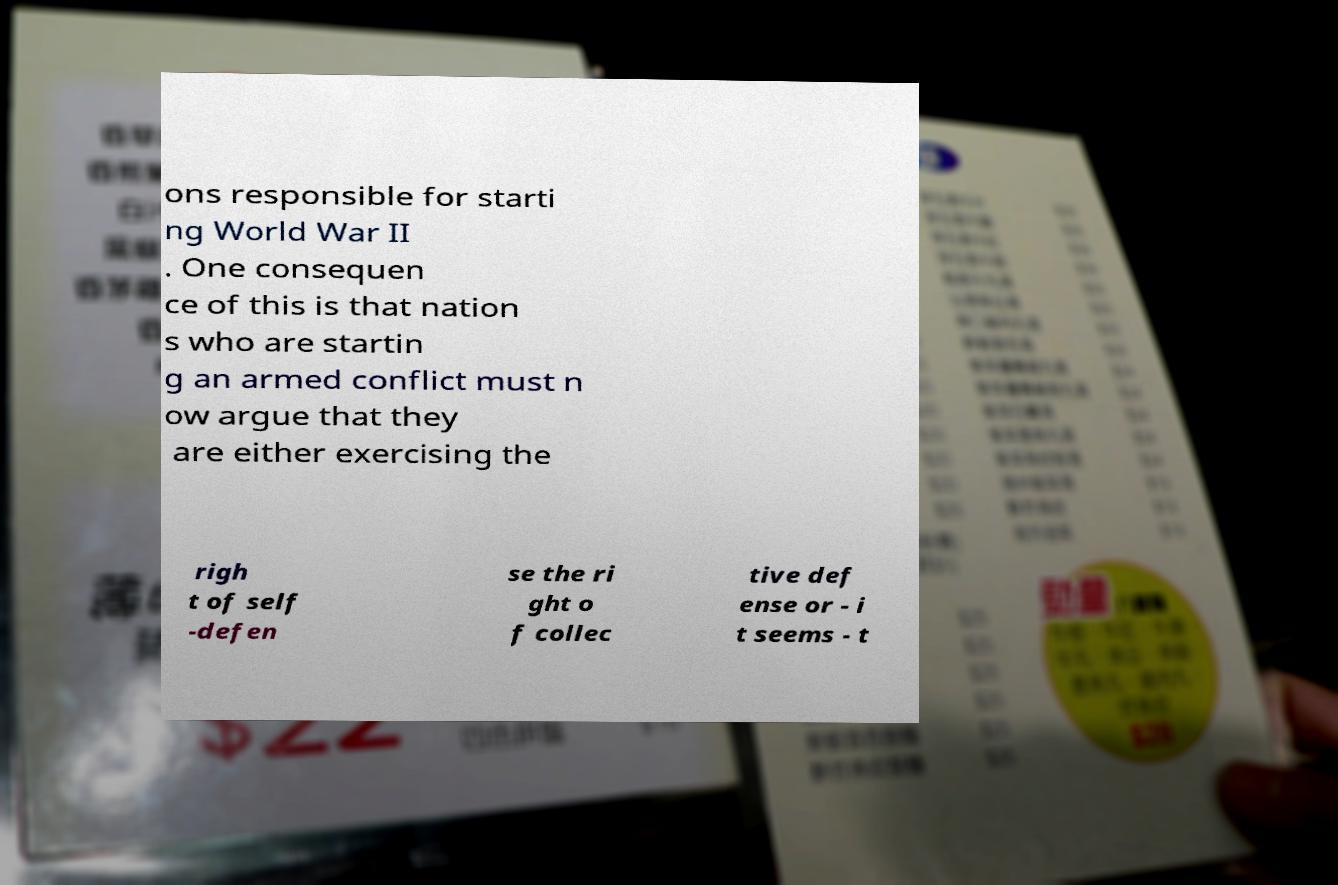Can you accurately transcribe the text from the provided image for me? ons responsible for starti ng World War II . One consequen ce of this is that nation s who are startin g an armed conflict must n ow argue that they are either exercising the righ t of self -defen se the ri ght o f collec tive def ense or - i t seems - t 